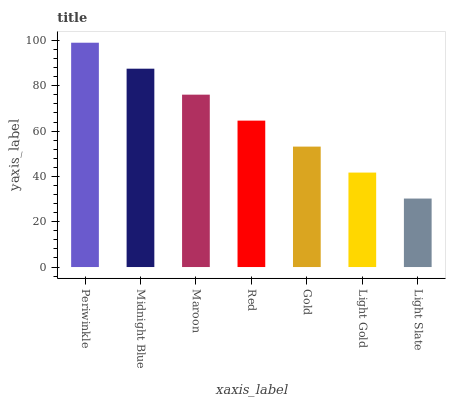Is Light Slate the minimum?
Answer yes or no. Yes. Is Periwinkle the maximum?
Answer yes or no. Yes. Is Midnight Blue the minimum?
Answer yes or no. No. Is Midnight Blue the maximum?
Answer yes or no. No. Is Periwinkle greater than Midnight Blue?
Answer yes or no. Yes. Is Midnight Blue less than Periwinkle?
Answer yes or no. Yes. Is Midnight Blue greater than Periwinkle?
Answer yes or no. No. Is Periwinkle less than Midnight Blue?
Answer yes or no. No. Is Red the high median?
Answer yes or no. Yes. Is Red the low median?
Answer yes or no. Yes. Is Gold the high median?
Answer yes or no. No. Is Gold the low median?
Answer yes or no. No. 